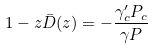<formula> <loc_0><loc_0><loc_500><loc_500>1 - z \bar { D } ( z ) = - \frac { \gamma ^ { \prime } _ { c } P _ { c } } { \gamma P }</formula> 